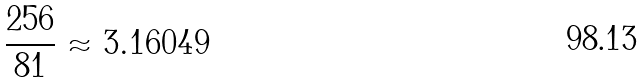<formula> <loc_0><loc_0><loc_500><loc_500>\frac { 2 5 6 } { 8 1 } \approx 3 . 1 6 0 4 9</formula> 